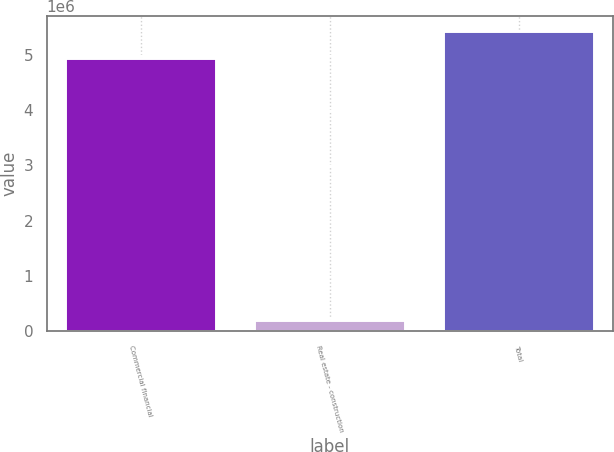<chart> <loc_0><loc_0><loc_500><loc_500><bar_chart><fcel>Commercial financial<fcel>Real estate - construction<fcel>Total<nl><fcel>4.93513e+06<fcel>203576<fcel>5.42864e+06<nl></chart> 